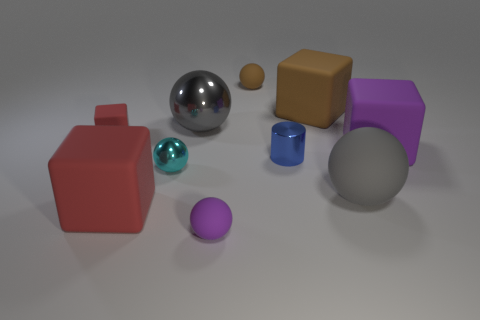Subtract all tiny rubber blocks. How many blocks are left? 3 Subtract 1 balls. How many balls are left? 4 Subtract all brown blocks. How many blocks are left? 3 Subtract all yellow cubes. Subtract all brown balls. How many cubes are left? 4 Subtract all cylinders. How many objects are left? 9 Add 1 large red matte objects. How many large red matte objects exist? 2 Subtract 1 cyan spheres. How many objects are left? 9 Subtract all tiny matte objects. Subtract all large red objects. How many objects are left? 6 Add 4 small cyan metallic spheres. How many small cyan metallic spheres are left? 5 